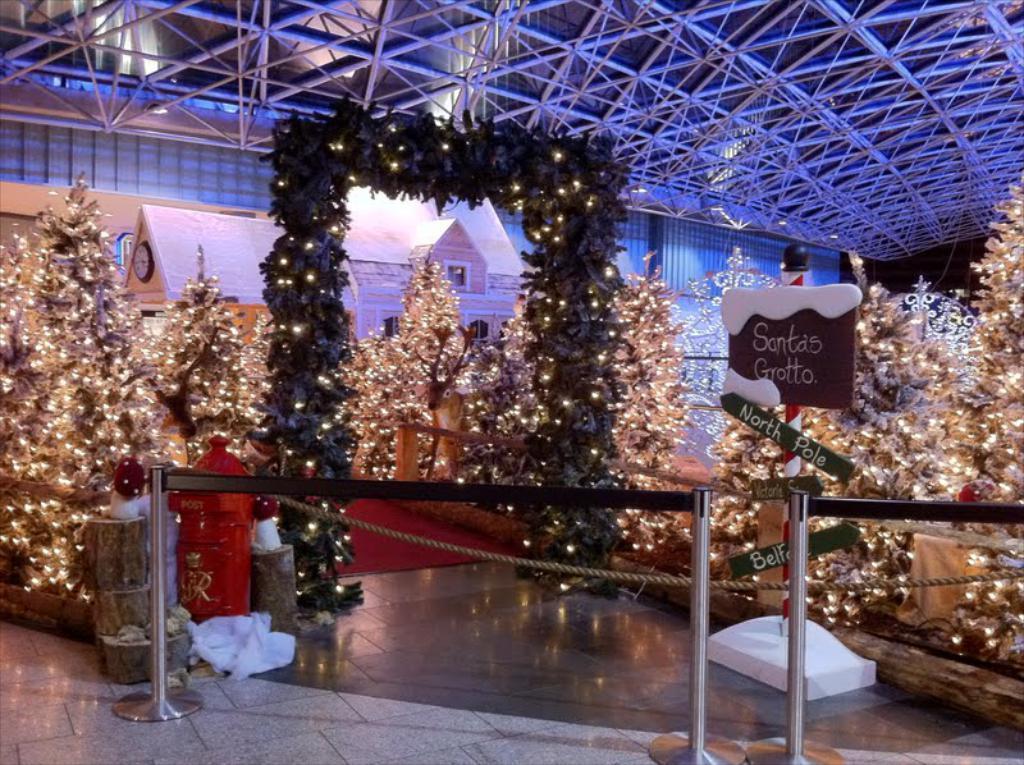Could you give a brief overview of what you see in this image? In this picture I can see decorative lights. I can see crowd control barriers. I can see Christmas trees. I can see the decorative house. 